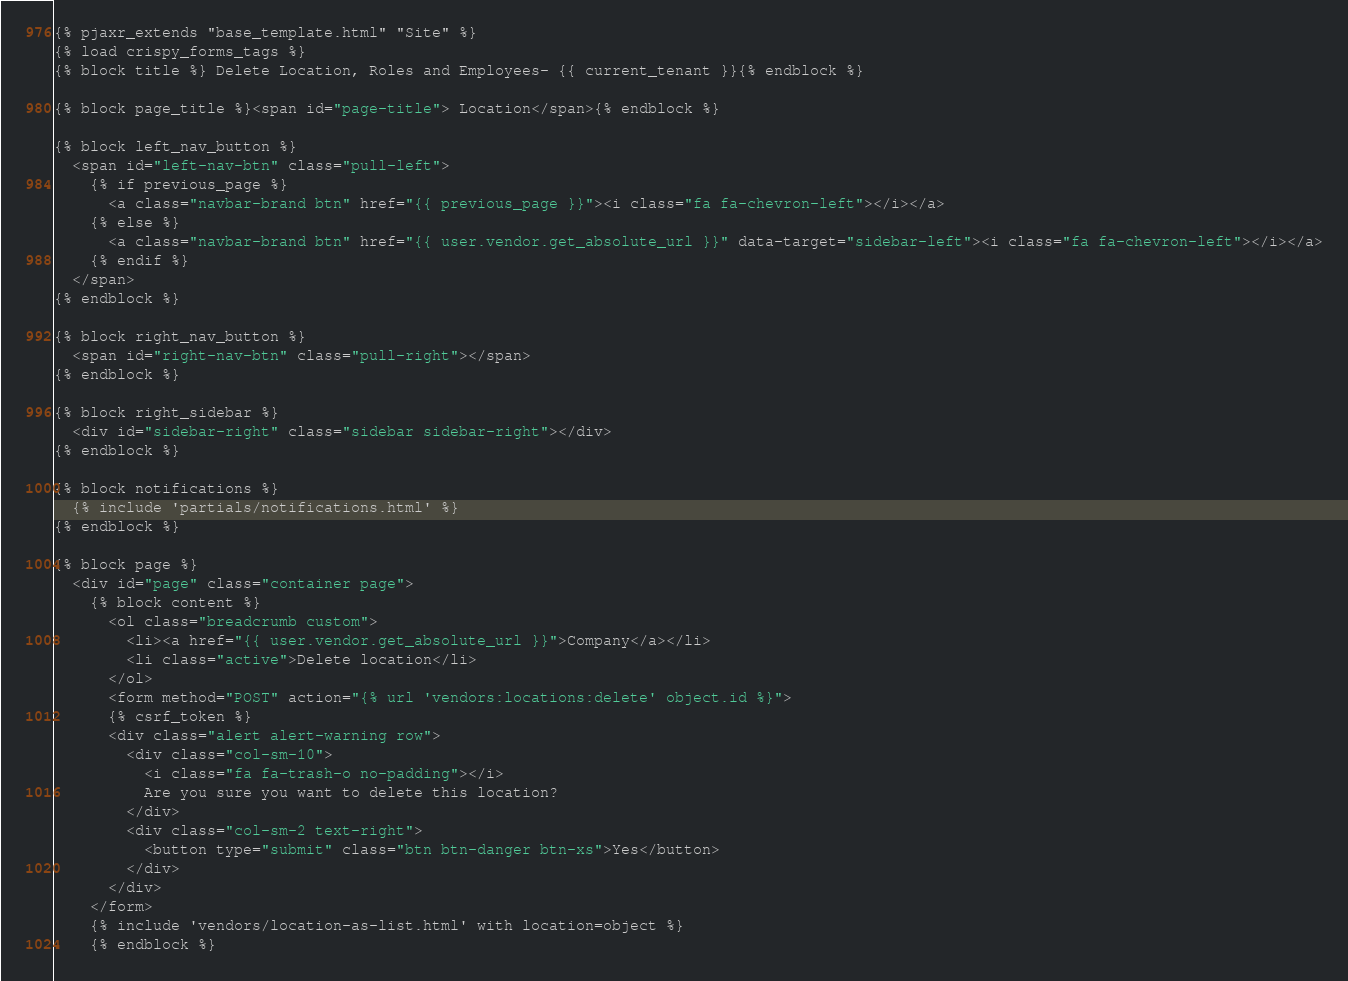Convert code to text. <code><loc_0><loc_0><loc_500><loc_500><_HTML_>{% pjaxr_extends "base_template.html" "Site" %}
{% load crispy_forms_tags %}
{% block title %} Delete Location, Roles and Employees- {{ current_tenant }}{% endblock %}

{% block page_title %}<span id="page-title"> Location</span>{% endblock %}

{% block left_nav_button %}
  <span id="left-nav-btn" class="pull-left">
    {% if previous_page %}
      <a class="navbar-brand btn" href="{{ previous_page }}"><i class="fa fa-chevron-left"></i></a>
    {% else %}
      <a class="navbar-brand btn" href="{{ user.vendor.get_absolute_url }}" data-target="sidebar-left"><i class="fa fa-chevron-left"></i></a>
    {% endif %}
  </span>
{% endblock %}

{% block right_nav_button %}
  <span id="right-nav-btn" class="pull-right"></span>
{% endblock %}

{% block right_sidebar %}
  <div id="sidebar-right" class="sidebar sidebar-right"></div>
{% endblock %}

{% block notifications %}
  {% include 'partials/notifications.html' %}
{% endblock %}

{% block page %}
  <div id="page" class="container page">
    {% block content %}
      <ol class="breadcrumb custom">
        <li><a href="{{ user.vendor.get_absolute_url }}">Company</a></li>
        <li class="active">Delete location</li>
      </ol>
      <form method="POST" action="{% url 'vendors:locations:delete' object.id %}">
      {% csrf_token %}
      <div class="alert alert-warning row">
        <div class="col-sm-10">
          <i class="fa fa-trash-o no-padding"></i>
          Are you sure you want to delete this location?
        </div>
        <div class="col-sm-2 text-right">
          <button type="submit" class="btn btn-danger btn-xs">Yes</button>
        </div>
      </div>
    </form>
    {% include 'vendors/location-as-list.html' with location=object %}
    {% endblock %}</code> 